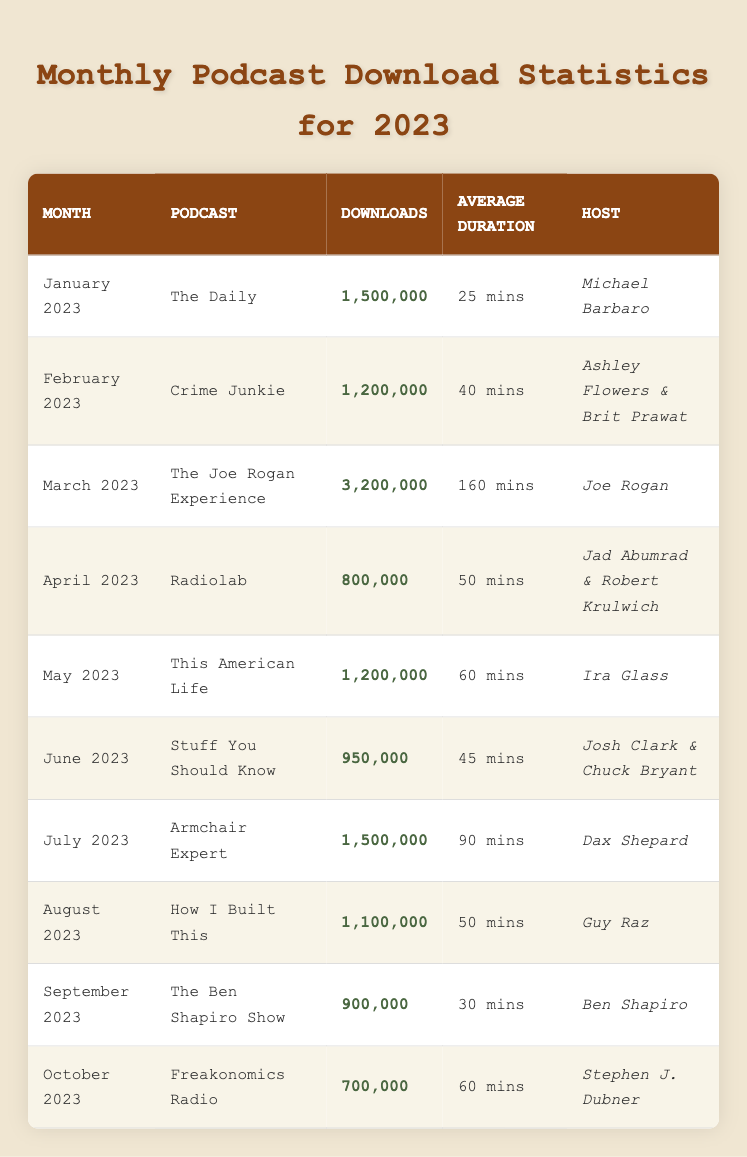What was the podcast with the highest downloads in March 2023? The table indicates that "The Joe Rogan Experience" had the highest downloads in March 2023 with 3,200,000 downloads.
Answer: The Joe Rogan Experience Which podcast had an average duration longer than 60 minutes? The table shows that "The Joe Rogan Experience" had an average duration of 160 minutes, which is longer than 60 minutes.
Answer: The Joe Rogan Experience How many total downloads did all podcasts receive in July and August combined? The downloads for July is 1,500,000 and for August is 1,100,000. Adding these gives 1,500,000 + 1,100,000 = 2,600,000 total downloads for those two months.
Answer: 2,600,000 Did "Stuff You Should Know" have more downloads than "Radiolab"? "Stuff You Should Know" had 950,000 downloads, while "Radiolab" had 800,000 downloads; therefore, it is true that "Stuff You Should Know" had more downloads.
Answer: Yes What is the average number of downloads for the first half of 2023 (January to June)? The downloads for January to June are 1,500,000, 1,200,000, 3,200,000, 800,000, 1,200,000, and 950,000. Summing these gives 8,850,000. There are 6 months, so the average is 8,850,000 / 6 = 1,475,000 downloads.
Answer: 1,475,000 Which podcast had the least number of downloads in 2023? Referring to the table, "Freakonomics Radio" had the least number of downloads at 700,000.
Answer: Freakonomics Radio How many podcasts had more than 1 million downloads in total for the year? By examining the data, the podcasts with more than 1 million downloads are "The Daily," "Crime Junkie," "The Joe Rogan Experience," "This American Life," and "Armchair Expert." That makes a total of 5 podcasts.
Answer: 5 Which month had the second most downloads overall, and what was the total? From the table, March had the highest downloads with 3,200,000, and July had 1,500,000. The second most downloads was from February with 1,200,000 downloads.
Answer: February 2023, 1,200,000 How many podcasts had a duration of at least 50 minutes? According to the table, April, May, July, August, and March all had durations of at least 50 minutes: "Radiolab," "This American Life," "Armchair Expert," "How I Built This," and "The Joe Rogan Experience." This results in a count of 5 podcasts.
Answer: 5 Which host had the most downloads for their podcast based on the data provided? Examining the downloads, "Joe Rogan" had the podcast "The Joe Rogan Experience," which received 3,200,000 downloads, the most for any single host.
Answer: Joe Rogan 